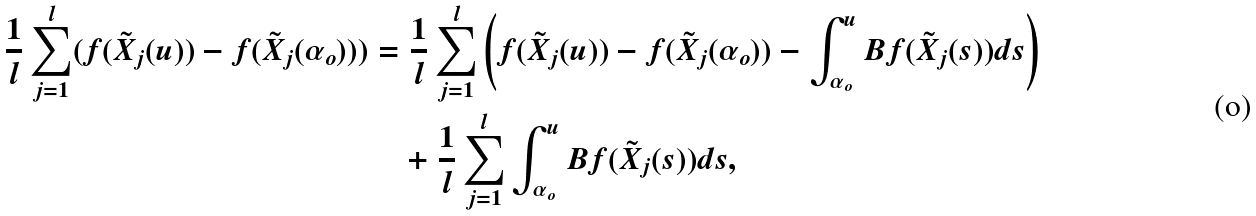Convert formula to latex. <formula><loc_0><loc_0><loc_500><loc_500>\frac { 1 } { l } \sum _ { j = 1 } ^ { l } ( f ( \tilde { X } _ { j } ( u ) ) - f ( \tilde { X } _ { j } ( \alpha _ { o } ) ) ) & = \frac { 1 } { l } \sum _ { j = 1 } ^ { l } \left ( f ( \tilde { X } _ { j } ( u ) ) - f ( \tilde { X } _ { j } ( \alpha _ { o } ) ) - \int ^ { u } _ { \alpha _ { o } } B f ( \tilde { X } _ { j } ( s ) ) d s \right ) \\ & \quad + \frac { 1 } { l } \sum _ { j = 1 } ^ { l } \int ^ { u } _ { \alpha _ { o } } B f ( \tilde { X } _ { j } ( s ) ) d s ,</formula> 